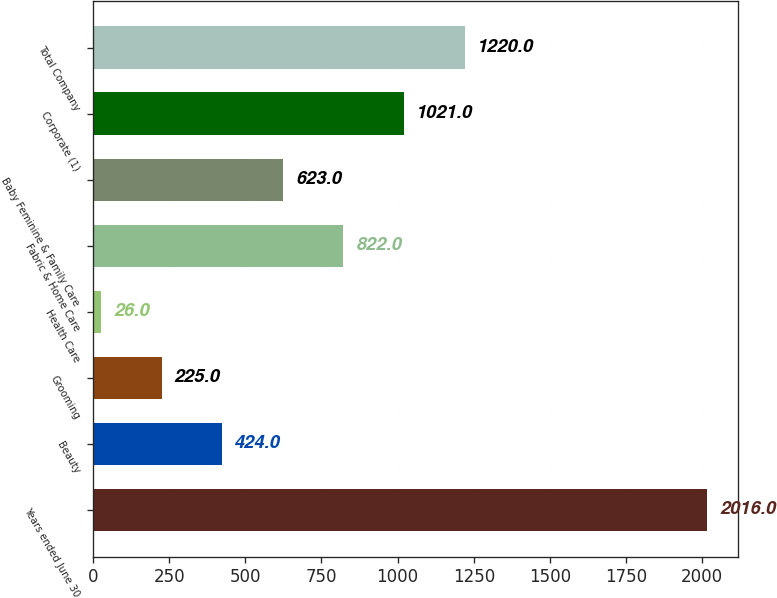<chart> <loc_0><loc_0><loc_500><loc_500><bar_chart><fcel>Years ended June 30<fcel>Beauty<fcel>Grooming<fcel>Health Care<fcel>Fabric & Home Care<fcel>Baby Feminine & Family Care<fcel>Corporate (1)<fcel>Total Company<nl><fcel>2016<fcel>424<fcel>225<fcel>26<fcel>822<fcel>623<fcel>1021<fcel>1220<nl></chart> 